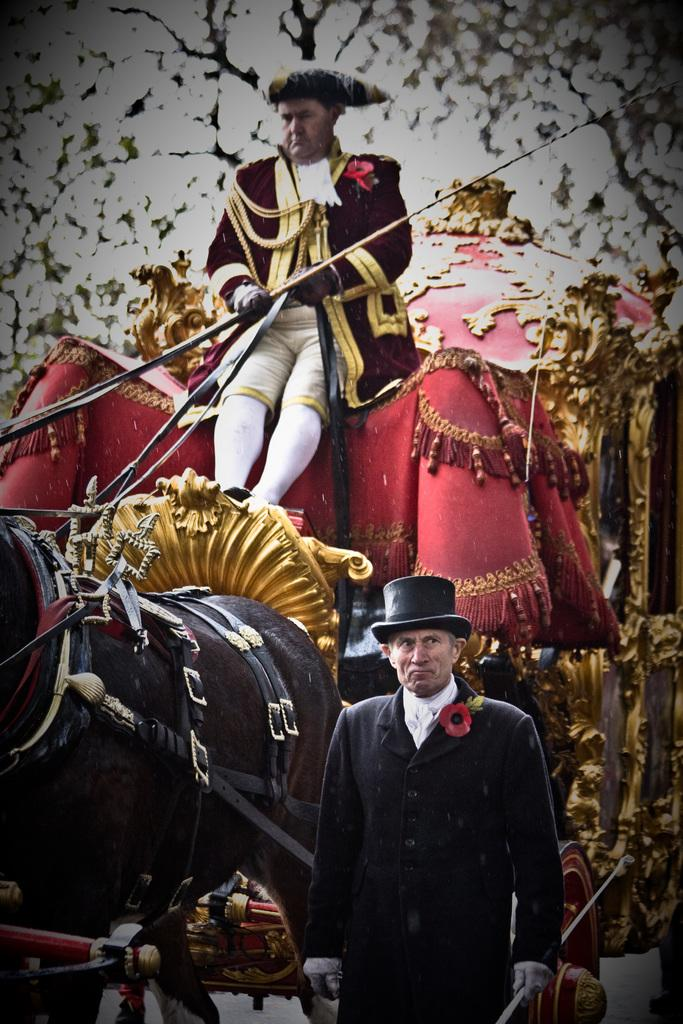What is the main subject in the middle of the image? There is a horse cart in the middle of the image. Who is sitting in the horse cart? There is a man sitting in the horse cart. What else can be seen in the image? There is a man standing in the image. Can you describe the standing man's attire? The standing man is wearing a hat. What type of lettuce is the man in the horse cart eating in the image? There is no lettuce present in the image, and the man in the horse cart is not eating anything. 